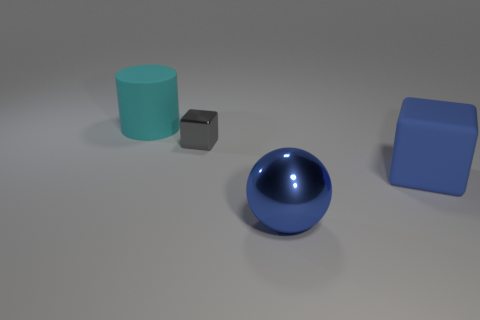There is a big rubber object that is to the right of the big blue metal thing; is there a big blue block behind it? Indeed, behind the large blue sphere, which you've referred to as the big blue metal thing, there appears to be no other object. Therefore, there isn't a big blue block positioned behind the blue sphere. 